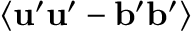Convert formula to latex. <formula><loc_0><loc_0><loc_500><loc_500>\langle { { u } ^ { \prime } { u } ^ { \prime } - { b } ^ { \prime } { b } ^ { \prime } } \rangle</formula> 